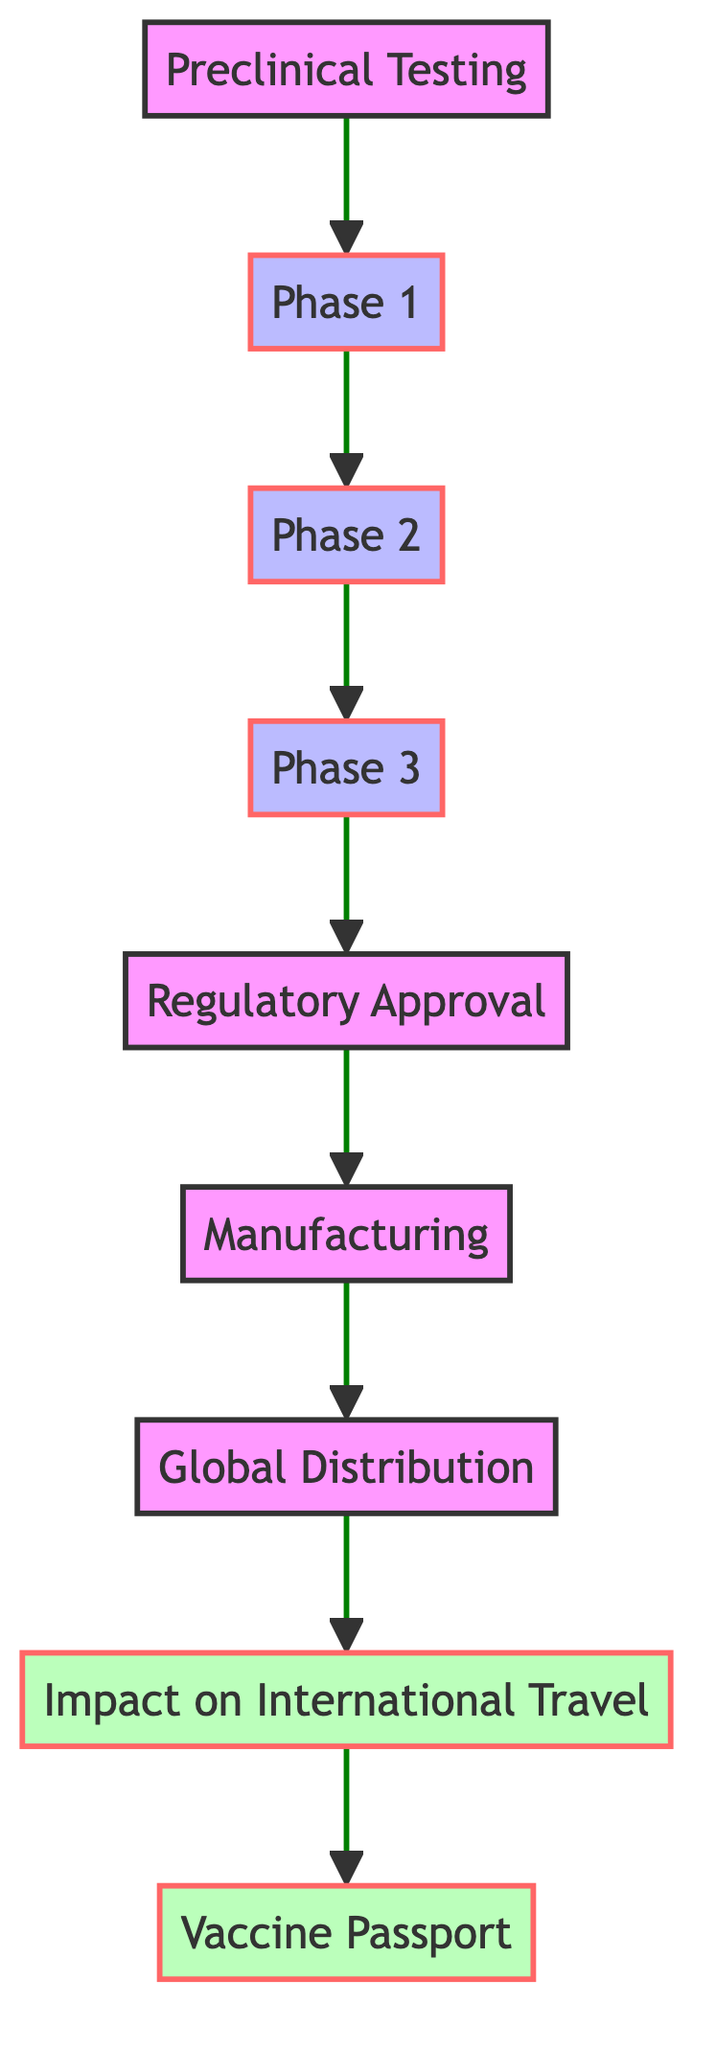What is the first phase in the vaccine development process? The diagram starts with "Preclinical Testing" as the first phase before proceeding to Phase 1, indicating it is the initial step in the vaccine development process.
Answer: Preclinical Testing How many phases are there in the vaccine development process? The diagram lists three phases after the preclinical stage (Phase 1, Phase 2, and Phase 3), totaling four significant stages in vaccine development.
Answer: Four What follows after regulatory approval in the vaccine development process? After "Regulatory Approval," the next step in the flowchart is "Manufacturing," showing the order of operations in the overall process.
Answer: Manufacturing What is the last node related to the impact of vaccines on travel? The final node related to the impact on travel indicates "Vaccine Passport," which illustrates a specific result of vaccine development that affects international travel.
Answer: Vaccine Passport How does the distribution of the vaccine relate to international travel? "Global Distribution" leads directly to "Impact on International Travel," indicating that the way the vaccine is distributed affects international travel policies or practices.
Answer: Impact on International Travel In what phase does the vaccine begin manufacturing? The diagram shows that manufacturing begins right after "Regulatory Approval," highlighting that this phase only commences once the vaccine has been approved by regulatory bodies.
Answer: Manufacturing Which node represents the main focus of vaccine development’s impact on travel? The main focus of vaccine development’s impact on travel is found at the node "Impact on International Travel," which directly follows the distribution phase.
Answer: Impact on International Travel What is the relationship between Phase 3 and Regulatory Approval? The diagram indicates that "Phase 3" leads directly to "Regulatory Approval," showing that the completion of Phase 3 is necessary prior to obtaining approval to use the vaccine.
Answer: Directly leads to How many types of impacts does the diagram mention concerning international travel? The diagram specifically highlights one type of impact concerning international travel, which is represented by the node "Vaccine Passport."
Answer: One 